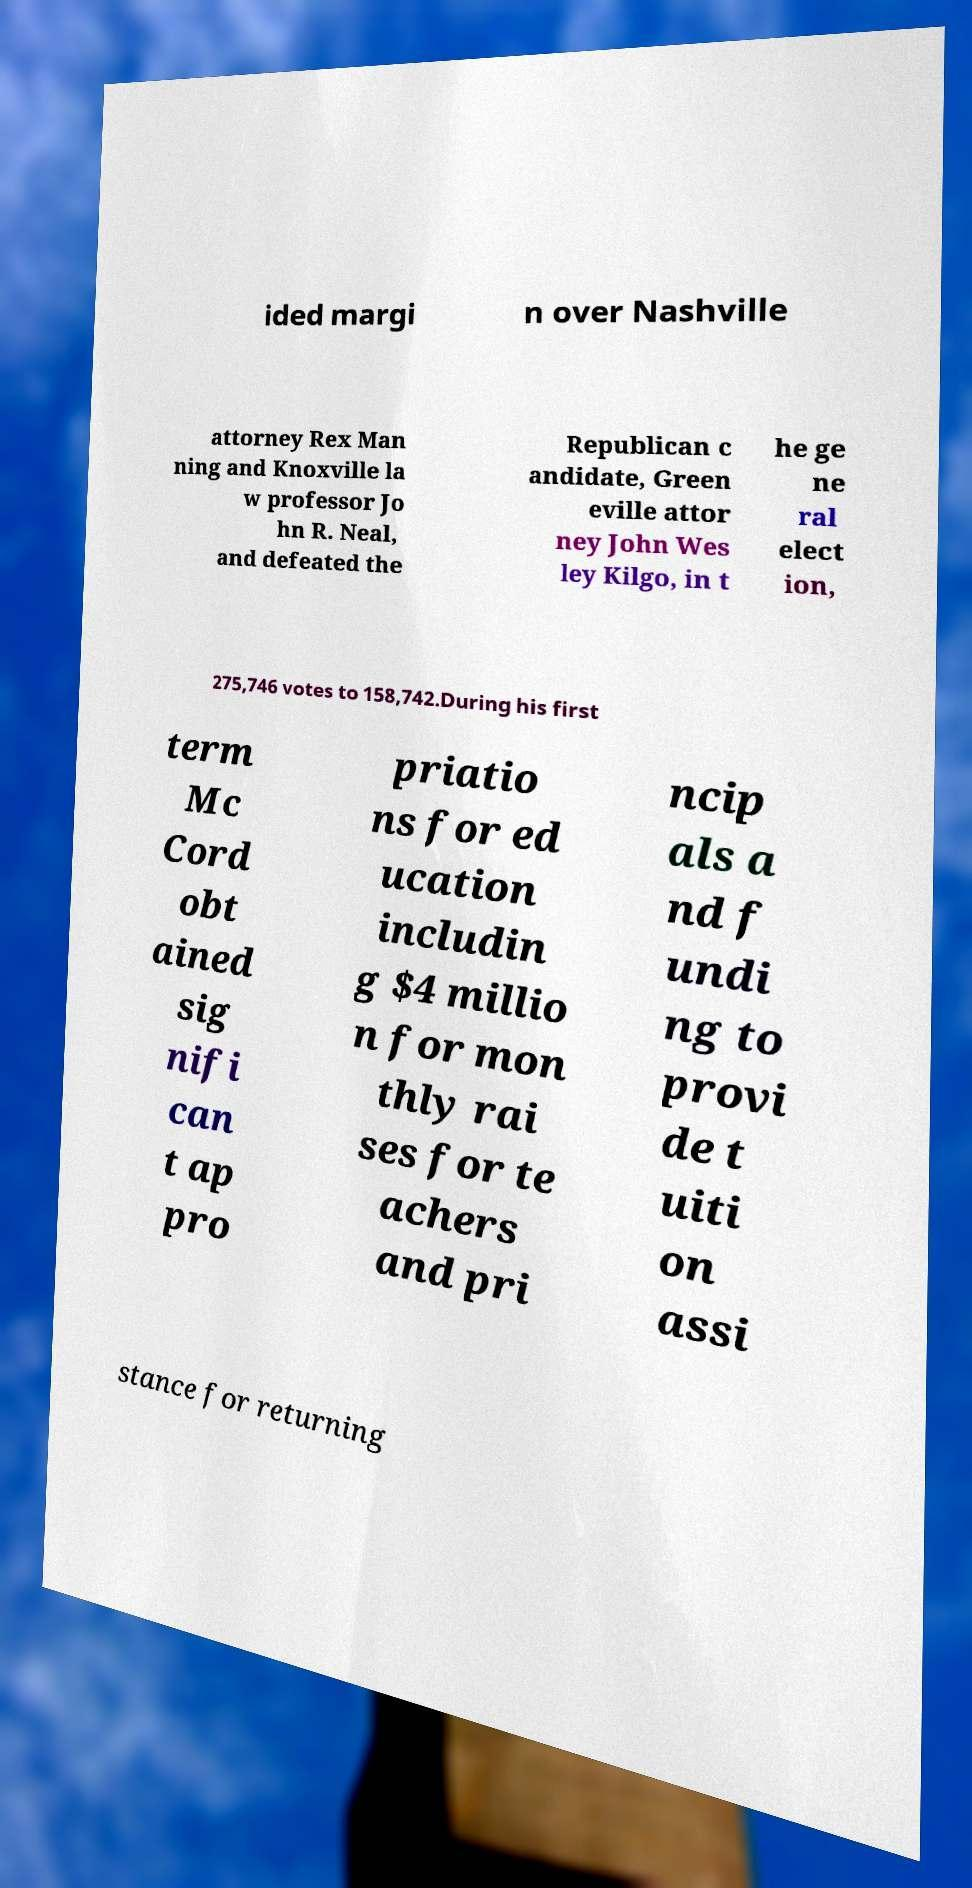I need the written content from this picture converted into text. Can you do that? ided margi n over Nashville attorney Rex Man ning and Knoxville la w professor Jo hn R. Neal, and defeated the Republican c andidate, Green eville attor ney John Wes ley Kilgo, in t he ge ne ral elect ion, 275,746 votes to 158,742.During his first term Mc Cord obt ained sig nifi can t ap pro priatio ns for ed ucation includin g $4 millio n for mon thly rai ses for te achers and pri ncip als a nd f undi ng to provi de t uiti on assi stance for returning 